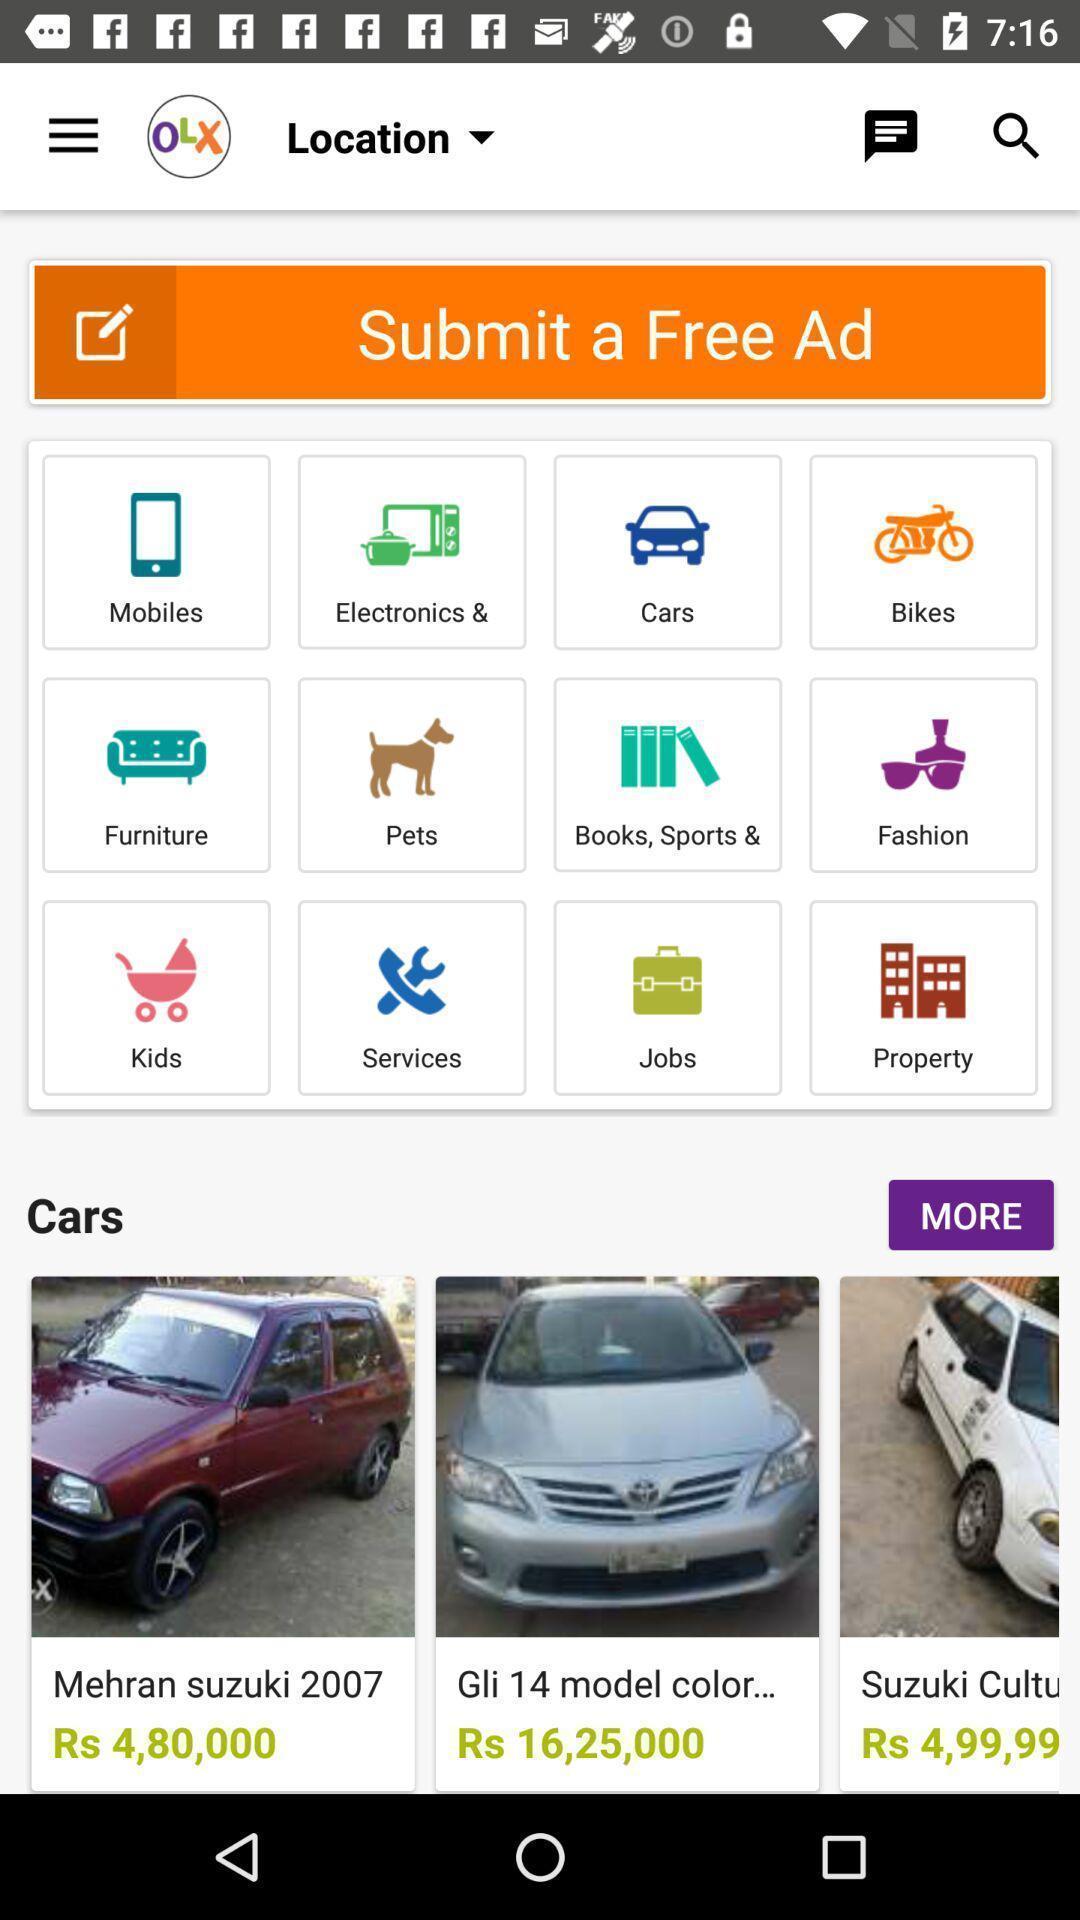Explain what's happening in this screen capture. Page displaying with different categories in shopping application. 